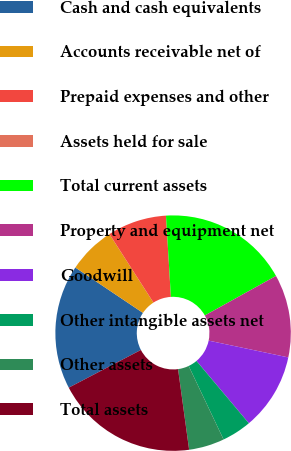Convert chart. <chart><loc_0><loc_0><loc_500><loc_500><pie_chart><fcel>Cash and cash equivalents<fcel>Accounts receivable net of<fcel>Prepaid expenses and other<fcel>Assets held for sale<fcel>Total current assets<fcel>Property and equipment net<fcel>Goodwill<fcel>Other intangible assets net<fcel>Other assets<fcel>Total assets<nl><fcel>17.07%<fcel>6.5%<fcel>8.13%<fcel>0.0%<fcel>17.89%<fcel>11.38%<fcel>10.57%<fcel>4.07%<fcel>4.88%<fcel>19.51%<nl></chart> 